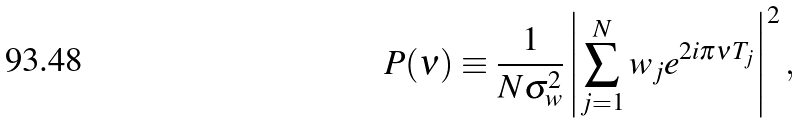<formula> <loc_0><loc_0><loc_500><loc_500>P ( \nu ) \equiv \frac { 1 } { N \sigma ^ { 2 } _ { w } } \left | \sum _ { j = 1 } ^ { N } w _ { j } e ^ { 2 i \pi \nu T _ { j } } \right | ^ { 2 } ,</formula> 